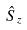Convert formula to latex. <formula><loc_0><loc_0><loc_500><loc_500>\hat { S } _ { z }</formula> 